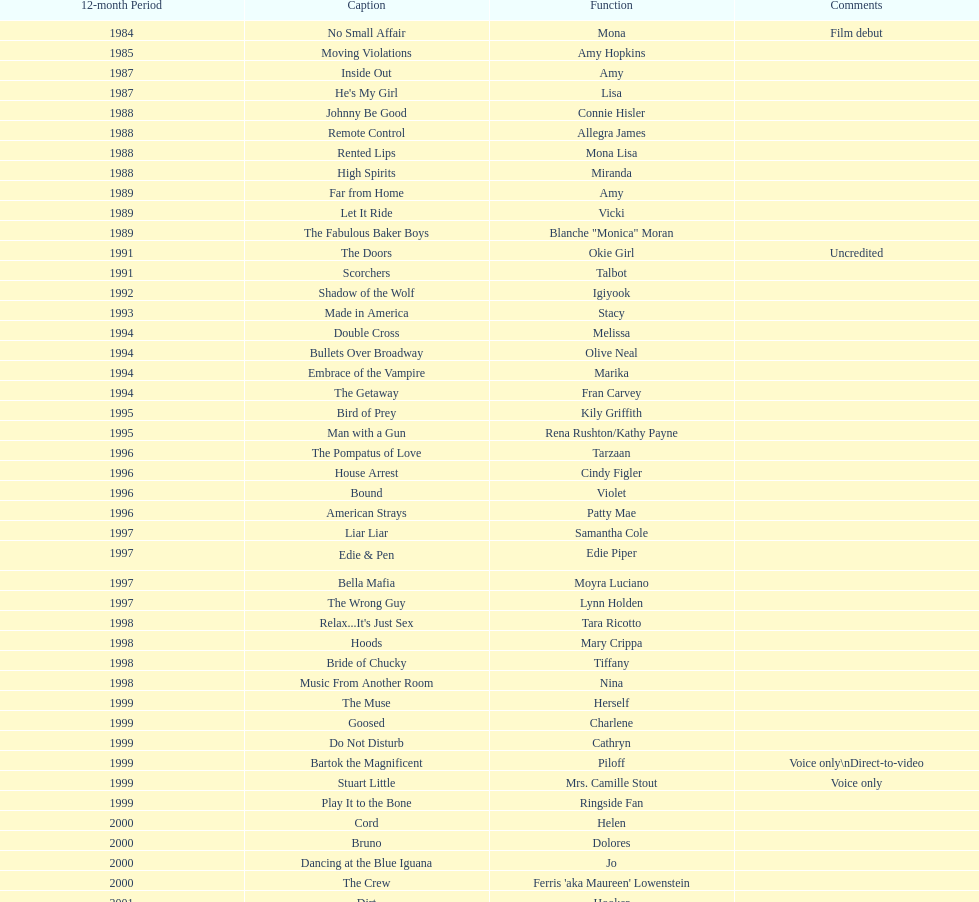Which film has their role under igiyook? Shadow of the Wolf. 